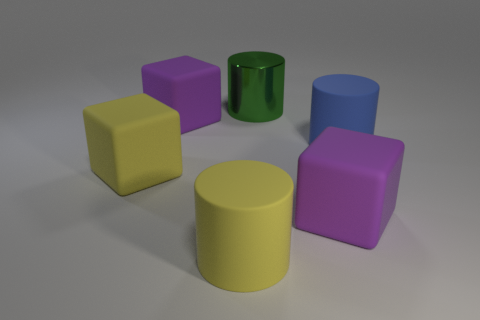How big is the thing that is in front of the metal cylinder and behind the blue matte thing?
Make the answer very short. Large. Are there fewer purple objects that are to the right of the metallic cylinder than big blue rubber objects behind the blue object?
Provide a succinct answer. No. Is the large purple thing that is right of the shiny object made of the same material as the big purple thing on the left side of the large green shiny thing?
Keep it short and to the point. Yes. What is the shape of the large thing that is both to the left of the yellow matte cylinder and in front of the large blue object?
Your answer should be very brief. Cube. There is a yellow thing that is on the left side of the large matte cylinder on the left side of the big blue object; what is its material?
Your answer should be compact. Rubber. Is the number of large purple things greater than the number of large yellow blocks?
Your response must be concise. Yes. There is a yellow cube that is the same size as the yellow cylinder; what is its material?
Offer a very short reply. Rubber. Are the blue cylinder and the green thing made of the same material?
Your response must be concise. No. How many big yellow cylinders are made of the same material as the blue cylinder?
Make the answer very short. 1. How many objects are purple matte cubes to the right of the shiny thing or large purple rubber blocks behind the blue matte object?
Give a very brief answer. 2. 